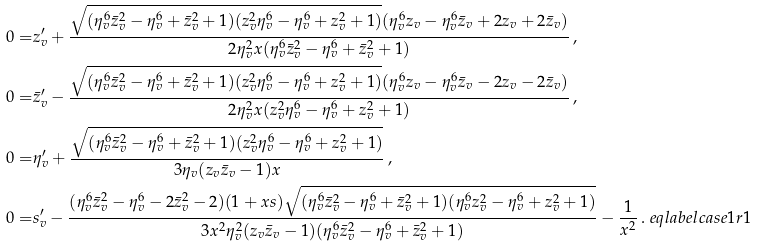<formula> <loc_0><loc_0><loc_500><loc_500>0 = & z _ { v } ^ { \prime } + \frac { \sqrt { ( \eta _ { v } ^ { 6 } \bar { z } _ { v } ^ { 2 } - \eta _ { v } ^ { 6 } + \bar { z } _ { v } ^ { 2 } + 1 ) ( z _ { v } ^ { 2 } \eta _ { v } ^ { 6 } - \eta _ { v } ^ { 6 } + z _ { v } ^ { 2 } + 1 ) } ( \eta _ { v } ^ { 6 } z _ { v } - \eta _ { v } ^ { 6 } \bar { z } _ { v } + 2 z _ { v } + 2 \bar { z } _ { v } ) } { 2 \eta _ { v } ^ { 2 } x ( \eta _ { v } ^ { 6 } \bar { z } _ { v } ^ { 2 } - \eta _ { v } ^ { 6 } + \bar { z } _ { v } ^ { 2 } + 1 ) } \, , \\ 0 = & \bar { z } _ { v } ^ { \prime } - \frac { \sqrt { ( \eta _ { v } ^ { 6 } \bar { z } _ { v } ^ { 2 } - \eta _ { v } ^ { 6 } + \bar { z } _ { v } ^ { 2 } + 1 ) ( z _ { v } ^ { 2 } \eta _ { v } ^ { 6 } - \eta _ { v } ^ { 6 } + z _ { v } ^ { 2 } + 1 ) } ( \eta _ { v } ^ { 6 } z _ { v } - \eta _ { v } ^ { 6 } \bar { z } _ { v } - 2 z _ { v } - 2 \bar { z } _ { v } ) } { 2 \eta _ { v } ^ { 2 } x ( z _ { v } ^ { 2 } \eta _ { v } ^ { 6 } - \eta _ { v } ^ { 6 } + z _ { v } ^ { 2 } + 1 ) } \, , \\ 0 = & \eta _ { v } ^ { \prime } + \frac { \sqrt { ( \eta _ { v } ^ { 6 } \bar { z } _ { v } ^ { 2 } - \eta _ { v } ^ { 6 } + \bar { z } _ { v } ^ { 2 } + 1 ) ( z _ { v } ^ { 2 } \eta _ { v } ^ { 6 } - \eta _ { v } ^ { 6 } + z _ { v } ^ { 2 } + 1 ) } } { 3 \eta _ { v } ( z _ { v } \bar { z } _ { v } - 1 ) x } \, , \\ 0 = & s _ { v } ^ { \prime } - \frac { ( \eta _ { v } ^ { 6 } \bar { z } _ { v } ^ { 2 } - \eta _ { v } ^ { 6 } - 2 \bar { z } _ { v } ^ { 2 } - 2 ) ( 1 + x s ) \sqrt { ( \eta _ { v } ^ { 6 } \bar { z } _ { v } ^ { 2 } - \eta _ { v } ^ { 6 } + \bar { z } _ { v } ^ { 2 } + 1 ) ( \eta _ { v } ^ { 6 } z _ { v } ^ { 2 } - \eta _ { v } ^ { 6 } + z _ { v } ^ { 2 } + 1 ) } } { 3 x ^ { 2 } \eta _ { v } ^ { 2 } ( z _ { v } \bar { z } _ { v } - 1 ) ( \eta _ { v } ^ { 6 } \bar { z } _ { v } ^ { 2 } - \eta _ { v } ^ { 6 } + \bar { z } _ { v } ^ { 2 } + 1 ) } - \frac { 1 } { x ^ { 2 } } \, . \ e q l a b e l { c a s e 1 r 1 }</formula> 